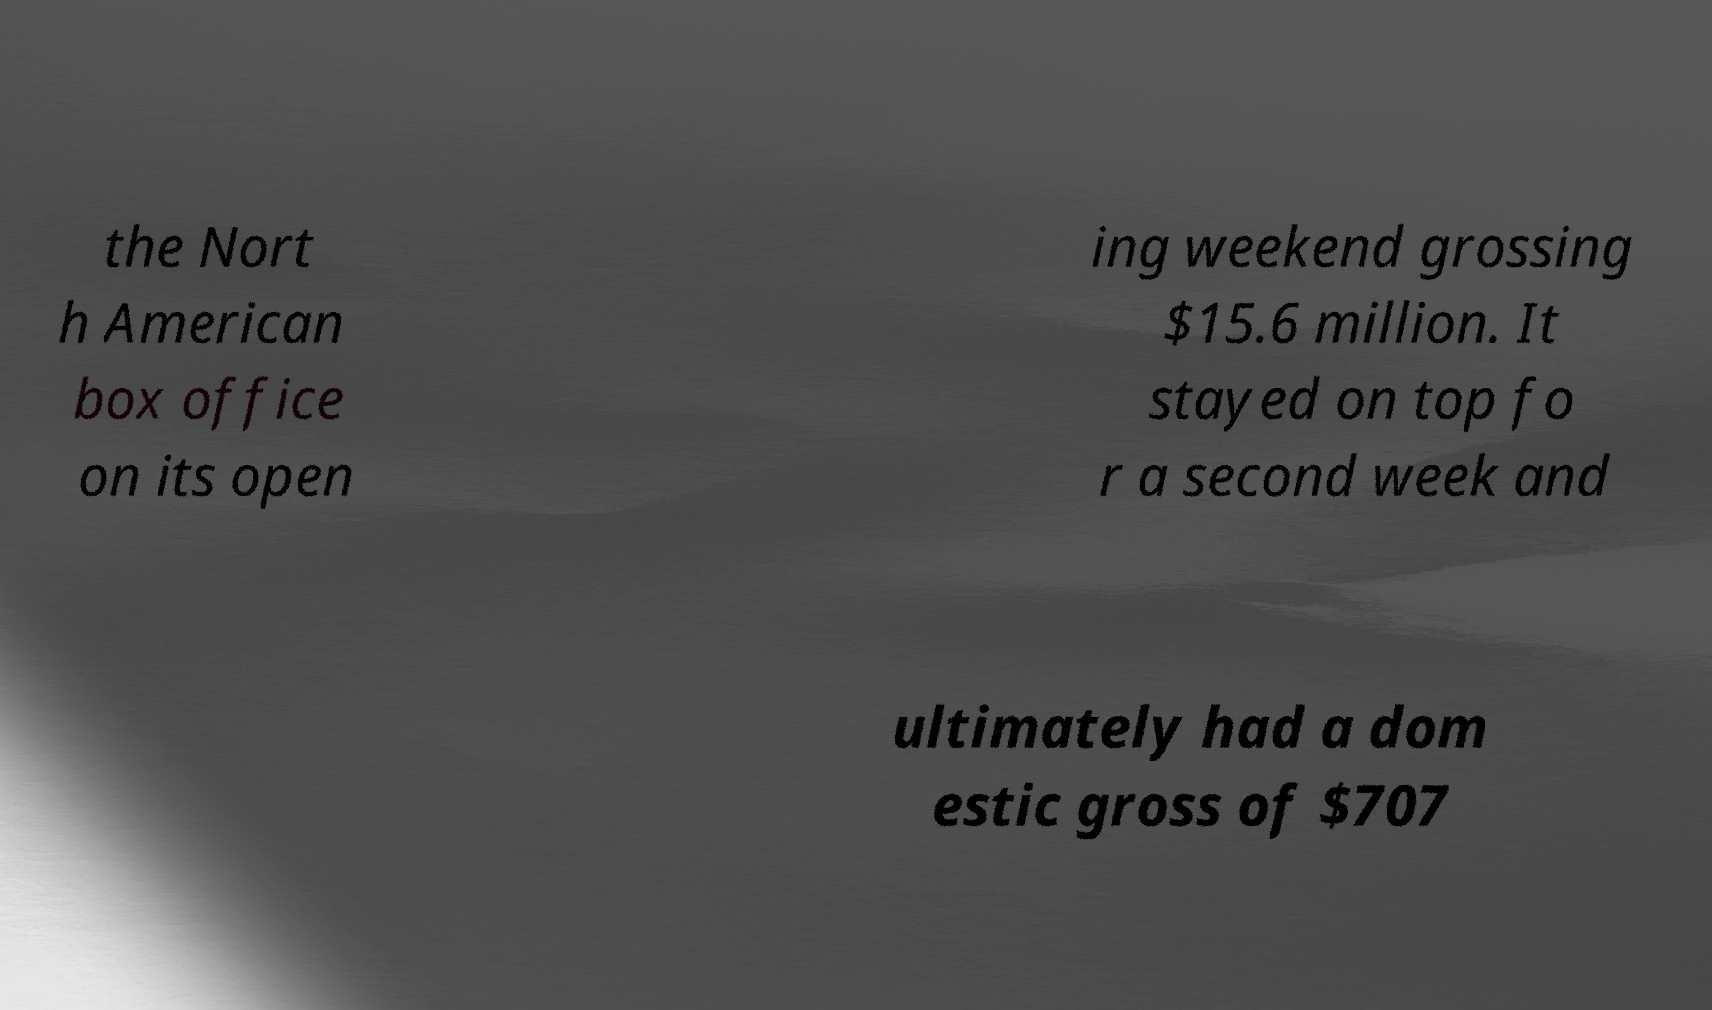For documentation purposes, I need the text within this image transcribed. Could you provide that? the Nort h American box office on its open ing weekend grossing $15.6 million. It stayed on top fo r a second week and ultimately had a dom estic gross of $707 